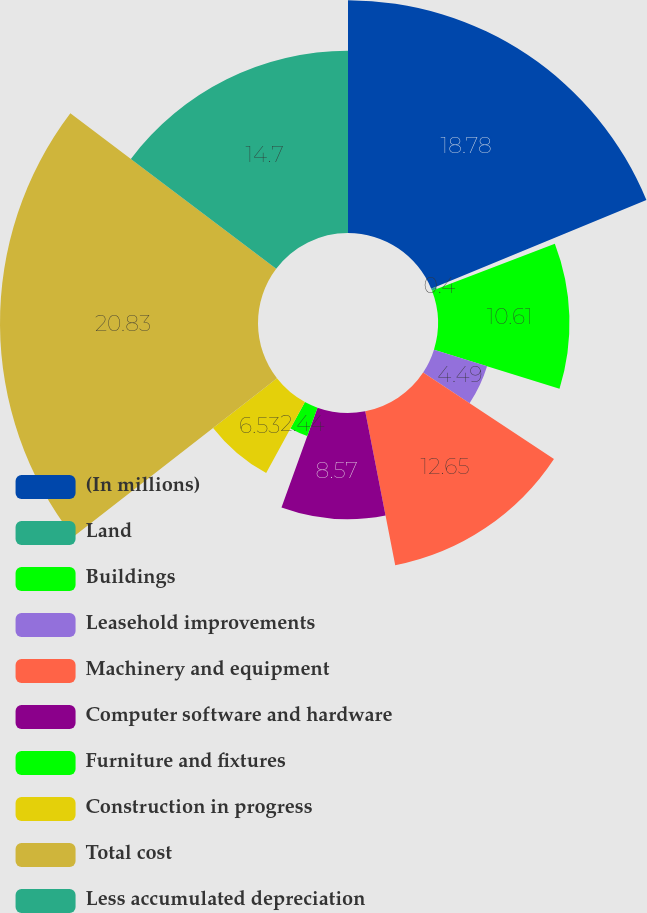Convert chart. <chart><loc_0><loc_0><loc_500><loc_500><pie_chart><fcel>(In millions)<fcel>Land<fcel>Buildings<fcel>Leasehold improvements<fcel>Machinery and equipment<fcel>Computer software and hardware<fcel>Furniture and fixtures<fcel>Construction in progress<fcel>Total cost<fcel>Less accumulated depreciation<nl><fcel>18.78%<fcel>0.4%<fcel>10.61%<fcel>4.49%<fcel>12.65%<fcel>8.57%<fcel>2.44%<fcel>6.53%<fcel>20.82%<fcel>14.7%<nl></chart> 